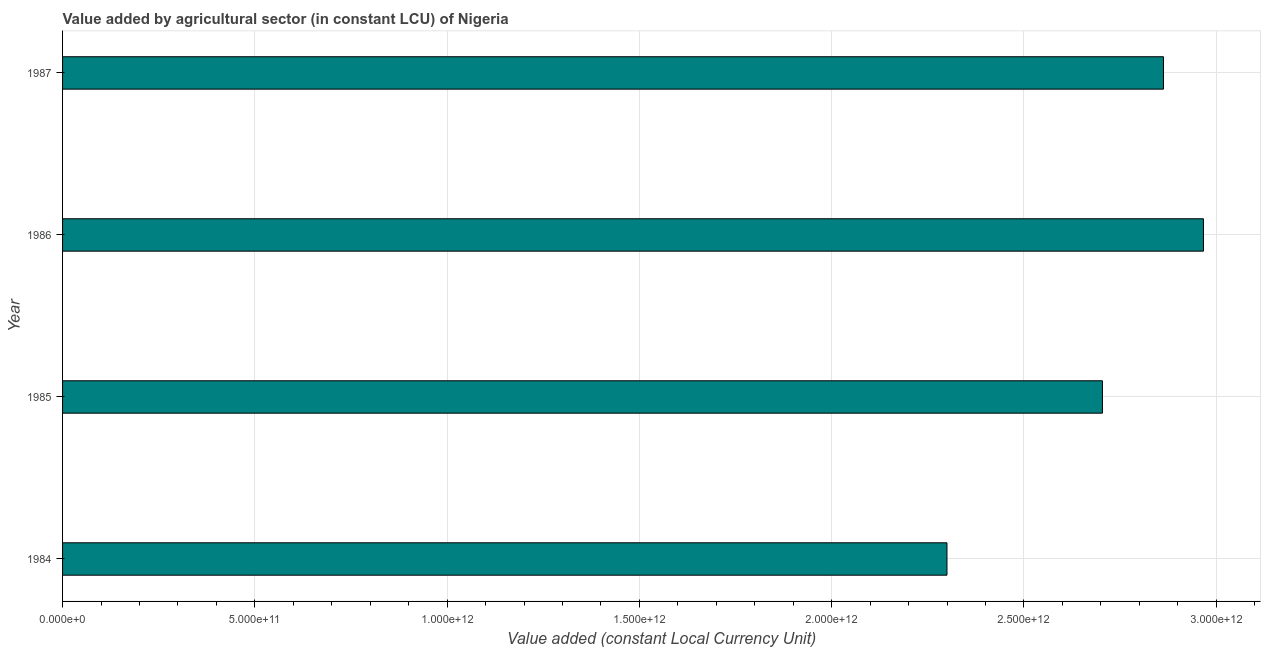Does the graph contain any zero values?
Your answer should be compact. No. Does the graph contain grids?
Provide a succinct answer. Yes. What is the title of the graph?
Keep it short and to the point. Value added by agricultural sector (in constant LCU) of Nigeria. What is the label or title of the X-axis?
Offer a terse response. Value added (constant Local Currency Unit). What is the value added by agriculture sector in 1987?
Your answer should be compact. 2.86e+12. Across all years, what is the maximum value added by agriculture sector?
Provide a succinct answer. 2.97e+12. Across all years, what is the minimum value added by agriculture sector?
Ensure brevity in your answer.  2.30e+12. What is the sum of the value added by agriculture sector?
Give a very brief answer. 1.08e+13. What is the difference between the value added by agriculture sector in 1986 and 1987?
Offer a very short reply. 1.04e+11. What is the average value added by agriculture sector per year?
Provide a succinct answer. 2.71e+12. What is the median value added by agriculture sector?
Offer a very short reply. 2.78e+12. In how many years, is the value added by agriculture sector greater than 2700000000000 LCU?
Make the answer very short. 3. What is the ratio of the value added by agriculture sector in 1985 to that in 1987?
Your answer should be compact. 0.94. Is the value added by agriculture sector in 1984 less than that in 1985?
Provide a short and direct response. Yes. Is the difference between the value added by agriculture sector in 1986 and 1987 greater than the difference between any two years?
Your response must be concise. No. What is the difference between the highest and the second highest value added by agriculture sector?
Provide a succinct answer. 1.04e+11. Is the sum of the value added by agriculture sector in 1984 and 1986 greater than the maximum value added by agriculture sector across all years?
Offer a very short reply. Yes. What is the difference between the highest and the lowest value added by agriculture sector?
Provide a succinct answer. 6.67e+11. In how many years, is the value added by agriculture sector greater than the average value added by agriculture sector taken over all years?
Provide a short and direct response. 2. How many bars are there?
Give a very brief answer. 4. What is the difference between two consecutive major ticks on the X-axis?
Give a very brief answer. 5.00e+11. Are the values on the major ticks of X-axis written in scientific E-notation?
Your answer should be very brief. Yes. What is the Value added (constant Local Currency Unit) of 1984?
Offer a very short reply. 2.30e+12. What is the Value added (constant Local Currency Unit) of 1985?
Provide a short and direct response. 2.70e+12. What is the Value added (constant Local Currency Unit) in 1986?
Make the answer very short. 2.97e+12. What is the Value added (constant Local Currency Unit) of 1987?
Your response must be concise. 2.86e+12. What is the difference between the Value added (constant Local Currency Unit) in 1984 and 1985?
Offer a very short reply. -4.04e+11. What is the difference between the Value added (constant Local Currency Unit) in 1984 and 1986?
Keep it short and to the point. -6.67e+11. What is the difference between the Value added (constant Local Currency Unit) in 1984 and 1987?
Give a very brief answer. -5.63e+11. What is the difference between the Value added (constant Local Currency Unit) in 1985 and 1986?
Your response must be concise. -2.63e+11. What is the difference between the Value added (constant Local Currency Unit) in 1985 and 1987?
Give a very brief answer. -1.59e+11. What is the difference between the Value added (constant Local Currency Unit) in 1986 and 1987?
Provide a short and direct response. 1.04e+11. What is the ratio of the Value added (constant Local Currency Unit) in 1984 to that in 1986?
Provide a short and direct response. 0.78. What is the ratio of the Value added (constant Local Currency Unit) in 1984 to that in 1987?
Your answer should be very brief. 0.8. What is the ratio of the Value added (constant Local Currency Unit) in 1985 to that in 1986?
Offer a very short reply. 0.91. What is the ratio of the Value added (constant Local Currency Unit) in 1985 to that in 1987?
Your answer should be compact. 0.94. What is the ratio of the Value added (constant Local Currency Unit) in 1986 to that in 1987?
Ensure brevity in your answer.  1.04. 